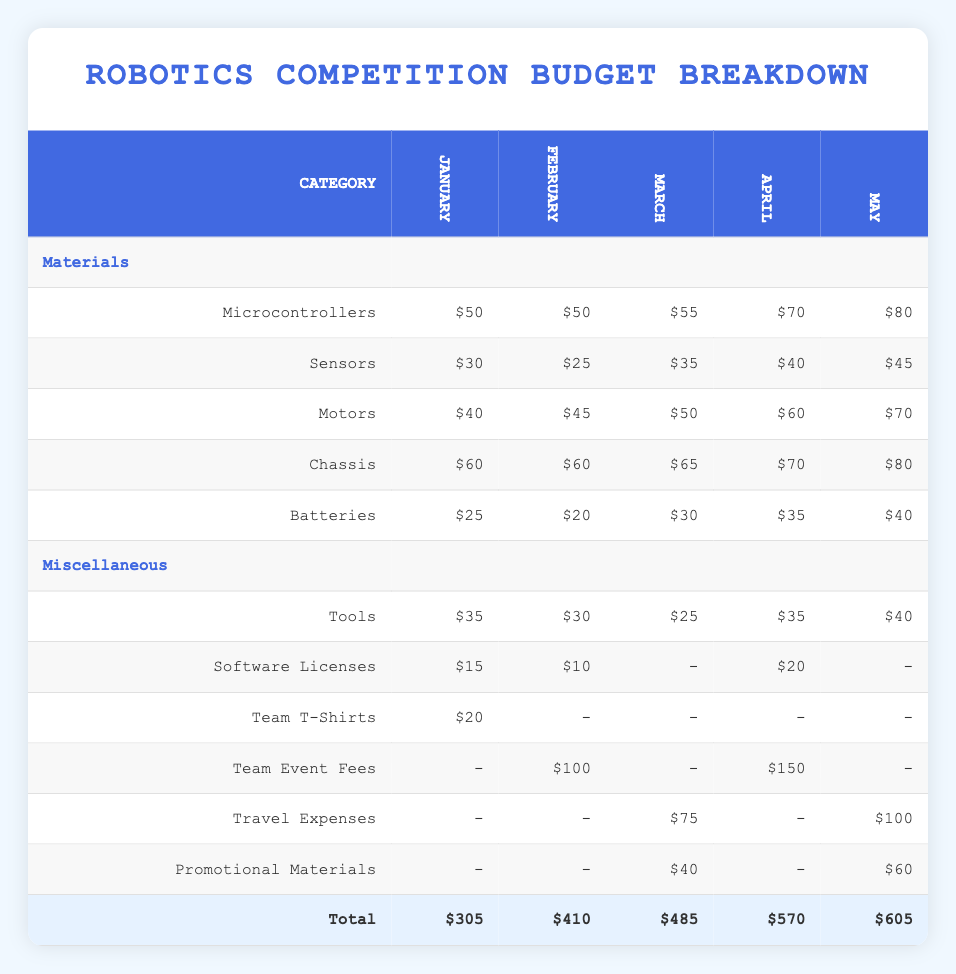What is the total amount spent on materials in March? To find the total amount spent on materials in March, we add up the costs listed under the "Materials" category for March: Microcontrollers ($55) + Sensors ($35) + Motors ($50) + Chassis ($65) + Batteries ($30) = $235.
Answer: 235 Which month had the highest total expense? To identify the month with the highest total expense, we compare the "Total" values for each month: January ($305), February ($410), March ($485), April ($570), May ($605). May has the highest total at $605.
Answer: May Did the expense for sensors increase every month? We analyze the values for sensors each month: January ($30), February ($25), March ($35), April ($40), May ($45). The expense does not increase every month, specifically it decreases in February.
Answer: No What was the increase in total expenses from January to May? To find the increase in total expenses from January to May, we subtract January's total from May's total: May total ($605) - January total ($305) = $300.
Answer: 300 How much was spent on promotional materials in February? Referring to the table, the expense for promotional materials in February is listed as "-" indicating that no money was spent.
Answer: 0 